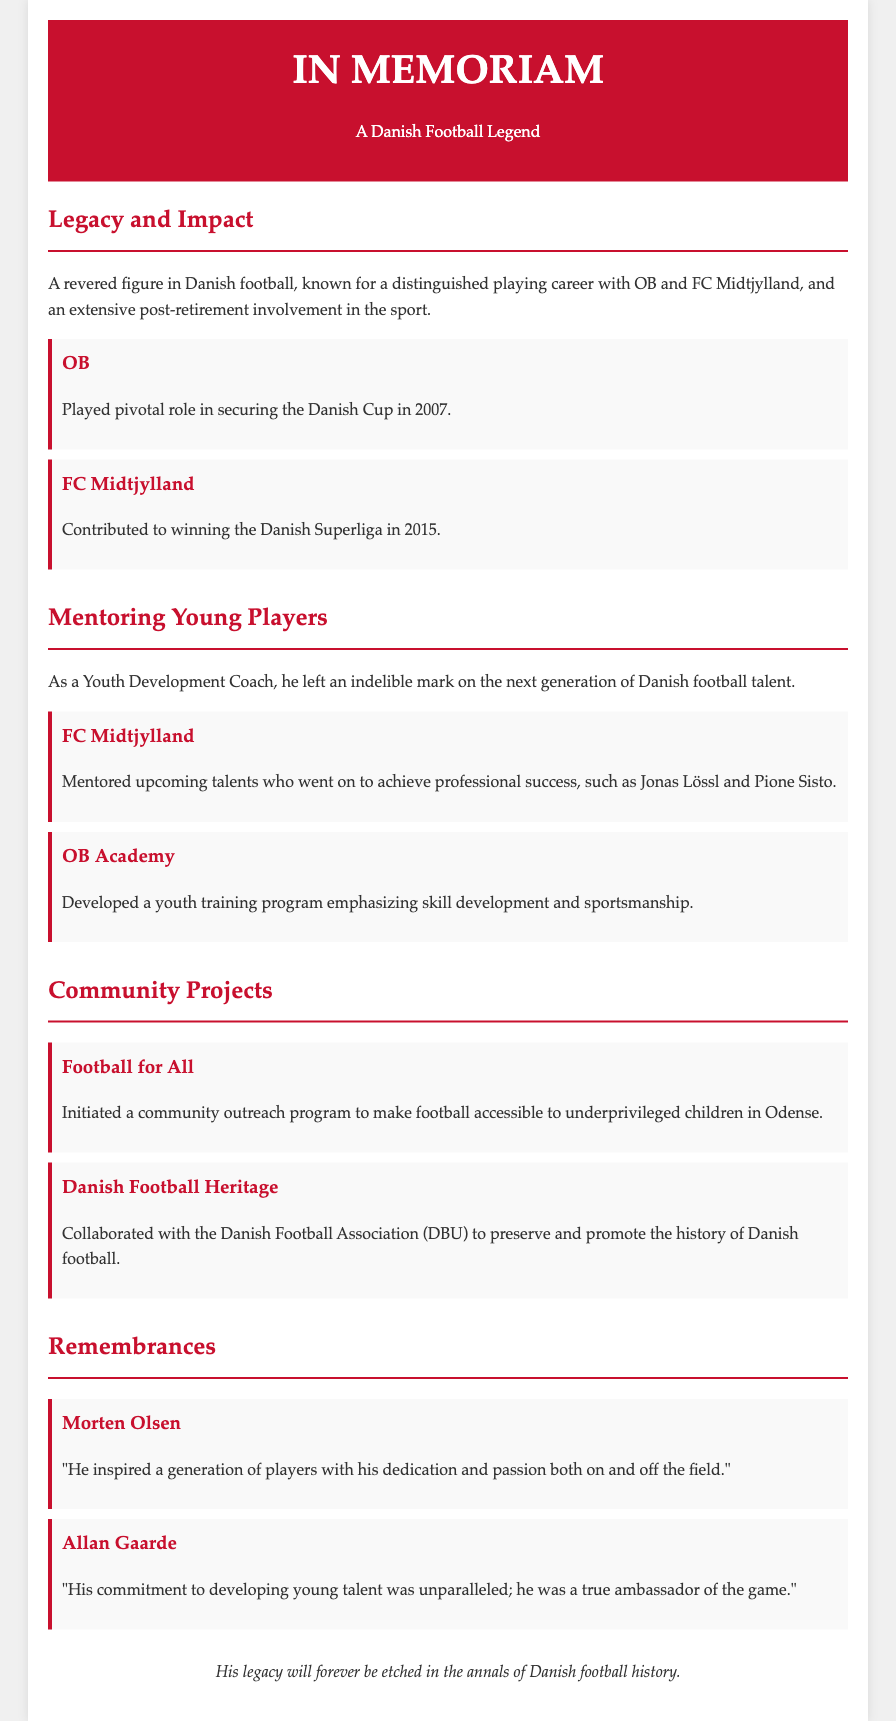what was a significant milestone achieved by OB? OB secured the Danish Cup in 2007.
Answer: Danish Cup in 2007 who did he mentor at FC Midtjylland? He mentored talents like Jonas Lössl and Pione Sisto.
Answer: Jonas Lössl and Pione Sisto what community project aimed to help underprivileged children? The project was called "Football for All."
Answer: Football for All which club did he contribute to winning the Danish Superliga? He contributed to FC Midtjylland winning the Danish Superliga.
Answer: FC Midtjylland who collaborated with the Danish Football Association to preserve football history? He collaborated with the Danish Football Association (DBU).
Answer: Danish Football Association (DBU) what was his role in youth development? He was a Youth Development Coach.
Answer: Youth Development Coach who described him as a true ambassador of the game? Allan Gaarde described him as a true ambassador of the game.
Answer: Allan Gaarde what year did FC Midtjylland win the Danish Superliga? They won it in 2015.
Answer: 2015 what type of training program did he develop at OB Academy? The program emphasized skill development and sportsmanship.
Answer: skill development and sportsmanship 